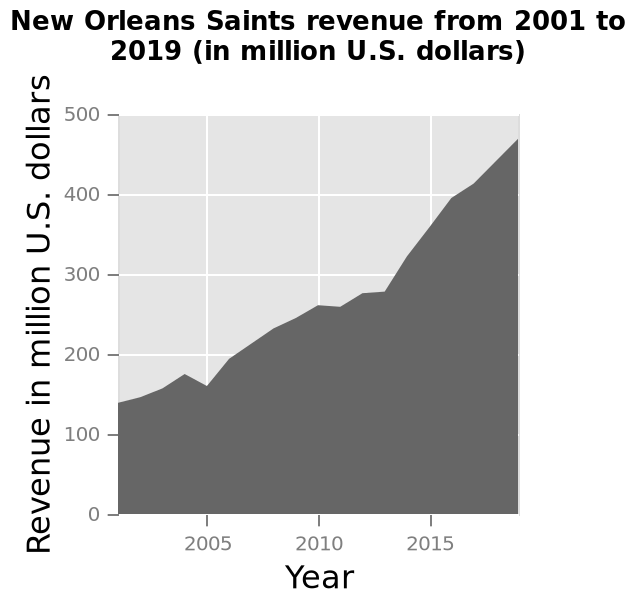<image>
How did the revenue in 2005 compare to 2004?  The revenue in 2005 dipped significantly compared to 2004. please enumerates aspects of the construction of the chart Here a area graph is titled New Orleans Saints revenue from 2001 to 2019 (in million U.S. dollars). A linear scale of range 2005 to 2015 can be seen along the x-axis, marked Year. Revenue in million U.S. dollars is measured on the y-axis. What is the time period covered by the graph? The graph covers the time period from 2001 to 2019. Which period showed the best growth in revenue? The period from 2013 to 2016 showed the best growth in revenue. Which year surpassed the previous best year of 2004? The revenue in 2006 surpassed the previous best year of 2004. What is the range of the linear scale on the x-axis?  The range of the linear scale on the x-axis is 2005 to 2015. Did the revenue in 2005 increase significantly compared to 2004? No. The revenue in 2005 dipped significantly compared to 2004. 